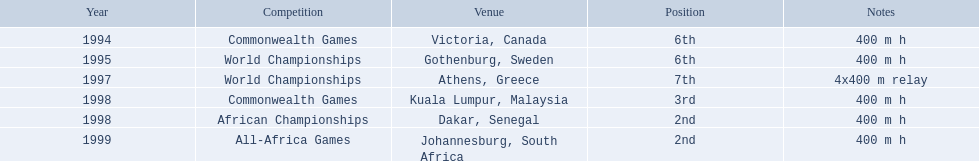Which competitions did ken harden participate in? 400 m h, 400 m h, 4x400 m relay, 400 m h, 400 m h, 400 m h. In 1997, which specific race was he a part of? 4x400 m relay. 